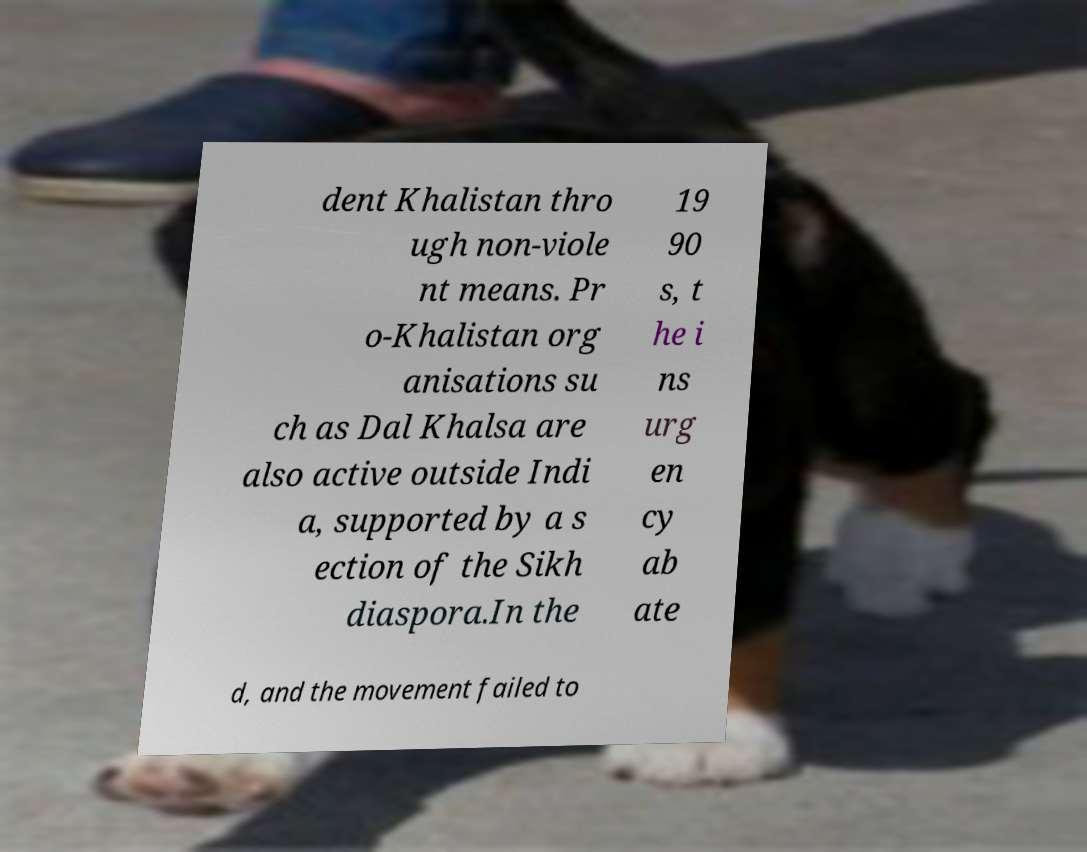Please read and relay the text visible in this image. What does it say? dent Khalistan thro ugh non-viole nt means. Pr o-Khalistan org anisations su ch as Dal Khalsa are also active outside Indi a, supported by a s ection of the Sikh diaspora.In the 19 90 s, t he i ns urg en cy ab ate d, and the movement failed to 